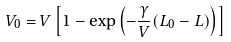<formula> <loc_0><loc_0><loc_500><loc_500>V _ { 0 } = V \left [ 1 - \exp \left ( - \frac { \gamma } { V } ( L _ { 0 } - L ) \right ) \right ]</formula> 